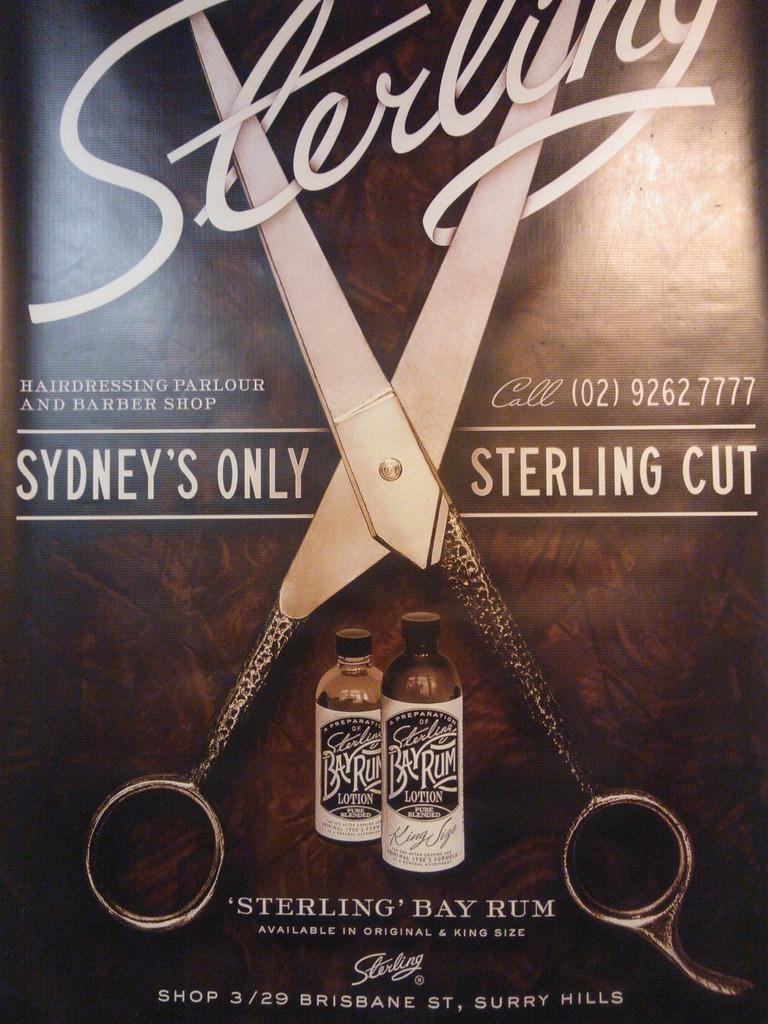<image>
Render a clear and concise summary of the photo. an ad for Sydney's Only Sterling Cut Bay Rum has scissors on it 